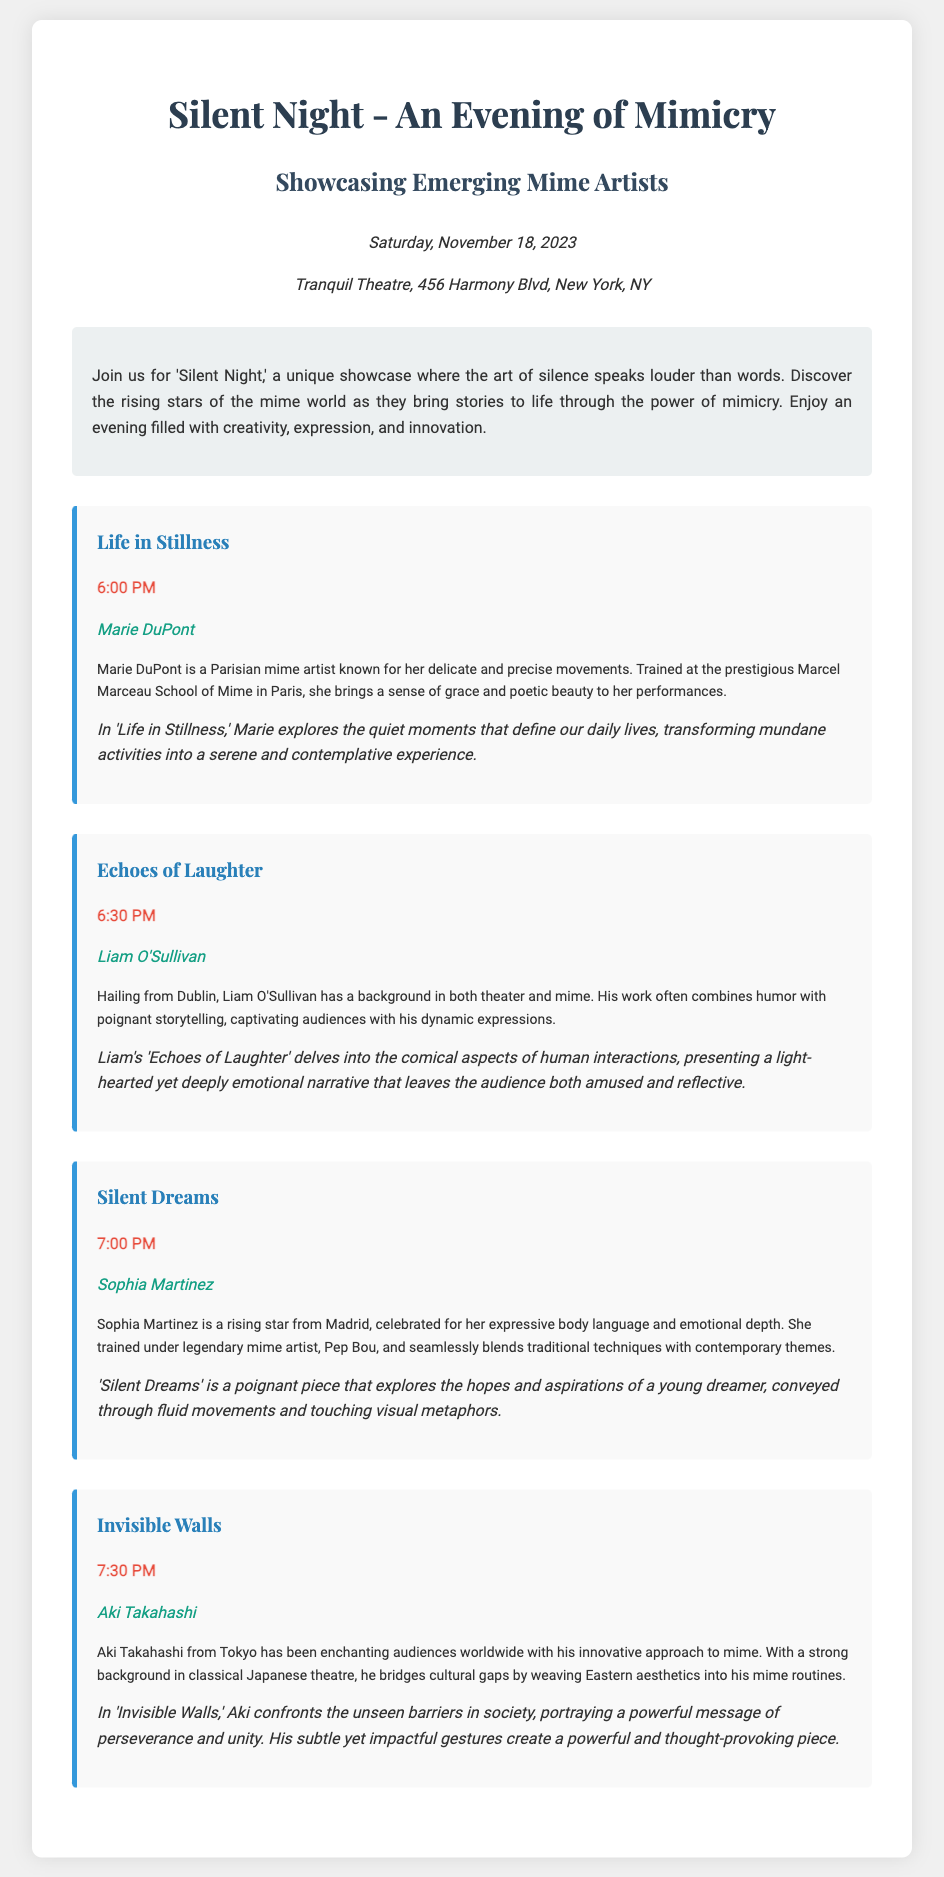What is the date of the event? The event is scheduled for Saturday, November 18, 2023.
Answer: November 18, 2023 Who is the artist performing "Life in Stillness"? The artist performing "Life in Stillness" is Marie DuPont.
Answer: Marie DuPont What is the performance time for "Silent Dreams"? The performance time for "Silent Dreams" is at 7:00 PM.
Answer: 7:00 PM Which city is Liam O'Sullivan from? Liam O'Sullivan hails from Dublin.
Answer: Dublin What theme does Aki Takahashi explore in "Invisible Walls"? Aki Takahashi confronts unseen barriers in society.
Answer: Unseen barriers Which mime artist trained under Pep Bou? Sophia Martinez trained under Pep Bou.
Answer: Sophia Martinez What style of performance is "Echoes of Laughter"? "Echoes of Laughter" combines humor with poignant storytelling.
Answer: Humor and storytelling What type of theatre background does Aki Takahashi have? Aki Takahashi has a strong background in classical Japanese theatre.
Answer: Classical Japanese theatre 